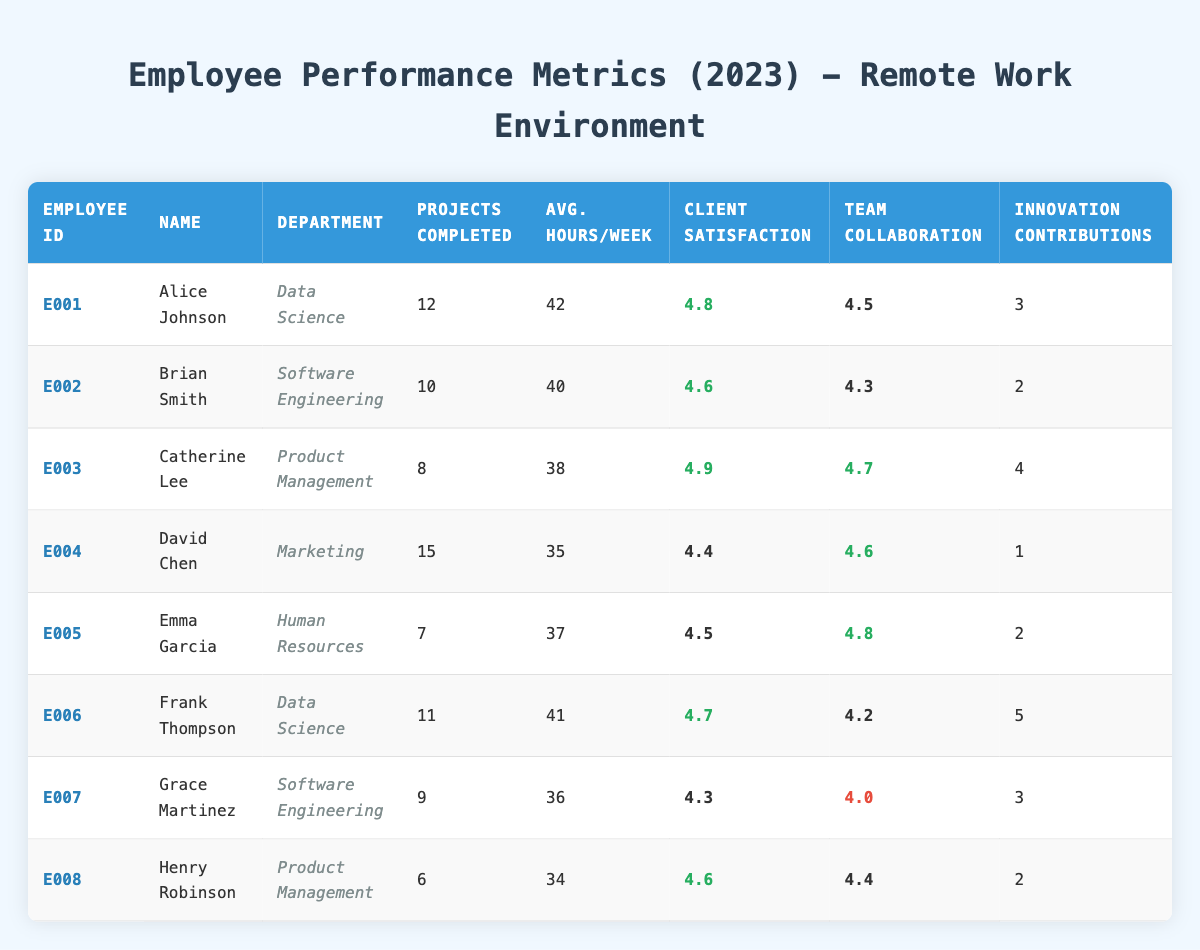What is the department of Alice Johnson? Alice Johnson is listed in the table under the "department" column, which shows her department as "Data Science."
Answer: Data Science How many projects did David Chen complete in 2023? Referring to the "projects completed" column, David Chen is associated with "15 projects completed."
Answer: 15 Which employee has the highest client satisfaction rating? By comparing the "client satisfaction rating" column, Catherine Lee has the highest rating at "4.9."
Answer: Catherine Lee What is the average client satisfaction rating across all employees? To calculate the average, sum all the client satisfaction ratings: (4.8 + 4.6 + 4.9 + 4.4 + 4.5 + 4.7 + 4.3 + 4.6) = 36.8. There are 8 employees, so the average is 36.8 / 8 = 4.6.
Answer: 4.6 Did any employee complete more than 15 projects? Reviewing the "projects completed" column, the maximum number listed is 15 completed by David Chen, which means no employee surpassed this number.
Answer: No Who worked the most average hours per week? The table shows average hours worked per week, where Alice Johnson has "42," and Frank Thompson has "41." Therefore, Alice Johnson worked the most.
Answer: Alice Johnson How many employees have a team collaboration score above 4.5? Assessing the "team collaboration score," Alice Johnson, Catherine Lee, David Chen, Emma Garcia, and Frank Thompson all score above 4.5, totaling five employees.
Answer: 5 What is the difference in projects completed between the highest and lowest performer? The highest is David Chen with "15 projects" and the lowest is Henry Robinson with "6 projects." The difference is calculated as 15 - 6 = 9.
Answer: 9 Does any employee from the Data Science department have a client satisfaction rating below 4.5? Checking both Data Science employees: Alice Johnson has "4.8" and Frank Thompson has "4.7," both above 4.5. Therefore, no employee from this department has a rating below 4.5.
Answer: No 